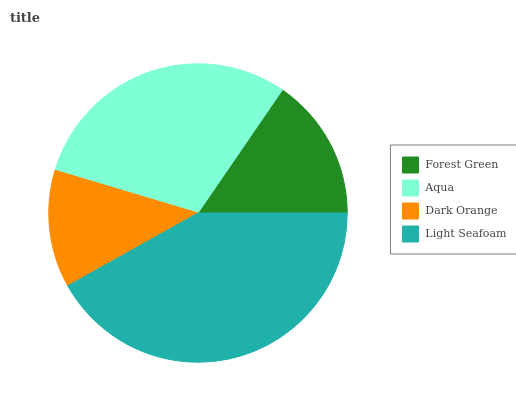Is Dark Orange the minimum?
Answer yes or no. Yes. Is Light Seafoam the maximum?
Answer yes or no. Yes. Is Aqua the minimum?
Answer yes or no. No. Is Aqua the maximum?
Answer yes or no. No. Is Aqua greater than Forest Green?
Answer yes or no. Yes. Is Forest Green less than Aqua?
Answer yes or no. Yes. Is Forest Green greater than Aqua?
Answer yes or no. No. Is Aqua less than Forest Green?
Answer yes or no. No. Is Aqua the high median?
Answer yes or no. Yes. Is Forest Green the low median?
Answer yes or no. Yes. Is Forest Green the high median?
Answer yes or no. No. Is Dark Orange the low median?
Answer yes or no. No. 